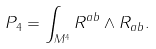Convert formula to latex. <formula><loc_0><loc_0><loc_500><loc_500>P _ { 4 } = \int _ { M ^ { 4 } } R ^ { a b } \wedge R _ { a b } .</formula> 